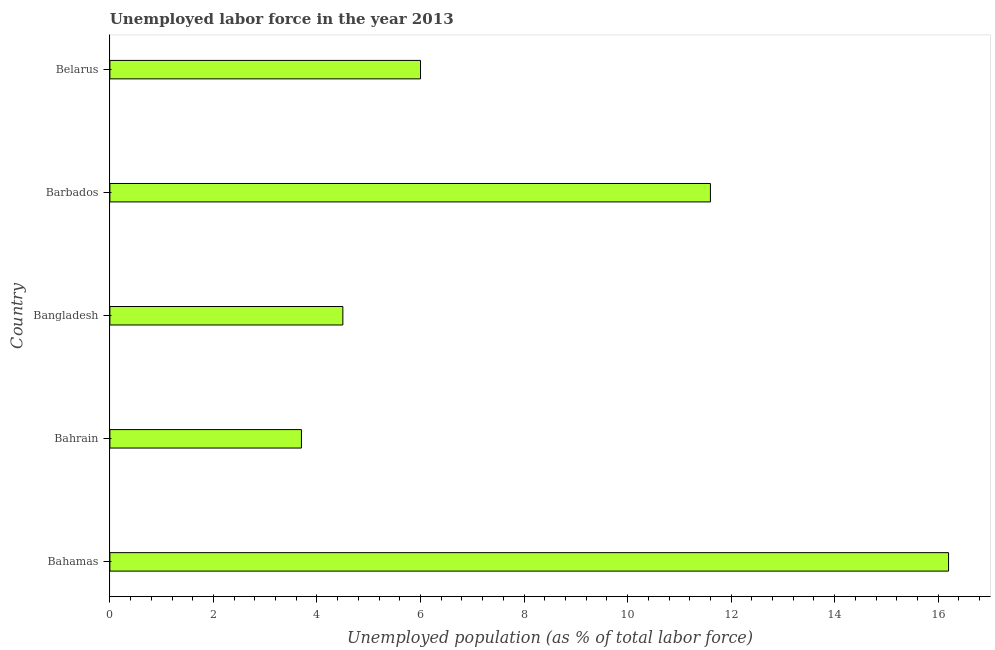Does the graph contain any zero values?
Provide a short and direct response. No. What is the title of the graph?
Your answer should be very brief. Unemployed labor force in the year 2013. What is the label or title of the X-axis?
Your response must be concise. Unemployed population (as % of total labor force). What is the label or title of the Y-axis?
Make the answer very short. Country. What is the total unemployed population in Barbados?
Your answer should be very brief. 11.6. Across all countries, what is the maximum total unemployed population?
Your answer should be very brief. 16.2. Across all countries, what is the minimum total unemployed population?
Offer a terse response. 3.7. In which country was the total unemployed population maximum?
Your answer should be compact. Bahamas. In which country was the total unemployed population minimum?
Provide a succinct answer. Bahrain. What is the sum of the total unemployed population?
Keep it short and to the point. 42. What is the difference between the total unemployed population in Bangladesh and Barbados?
Offer a very short reply. -7.1. What is the average total unemployed population per country?
Provide a succinct answer. 8.4. In how many countries, is the total unemployed population greater than 12 %?
Your answer should be compact. 1. What is the ratio of the total unemployed population in Bahrain to that in Belarus?
Provide a short and direct response. 0.62. Is the difference between the total unemployed population in Bangladesh and Barbados greater than the difference between any two countries?
Your answer should be compact. No. What is the difference between the highest and the second highest total unemployed population?
Your response must be concise. 4.6. Is the sum of the total unemployed population in Bahamas and Bahrain greater than the maximum total unemployed population across all countries?
Keep it short and to the point. Yes. In how many countries, is the total unemployed population greater than the average total unemployed population taken over all countries?
Make the answer very short. 2. How many bars are there?
Keep it short and to the point. 5. Are all the bars in the graph horizontal?
Make the answer very short. Yes. How many countries are there in the graph?
Provide a succinct answer. 5. What is the Unemployed population (as % of total labor force) in Bahamas?
Provide a succinct answer. 16.2. What is the Unemployed population (as % of total labor force) of Bahrain?
Your answer should be very brief. 3.7. What is the Unemployed population (as % of total labor force) of Bangladesh?
Provide a succinct answer. 4.5. What is the Unemployed population (as % of total labor force) in Barbados?
Offer a very short reply. 11.6. What is the Unemployed population (as % of total labor force) of Belarus?
Ensure brevity in your answer.  6. What is the difference between the Unemployed population (as % of total labor force) in Bahrain and Bangladesh?
Your answer should be compact. -0.8. What is the difference between the Unemployed population (as % of total labor force) in Bahrain and Barbados?
Give a very brief answer. -7.9. What is the difference between the Unemployed population (as % of total labor force) in Bangladesh and Barbados?
Your response must be concise. -7.1. What is the difference between the Unemployed population (as % of total labor force) in Bangladesh and Belarus?
Your answer should be very brief. -1.5. What is the ratio of the Unemployed population (as % of total labor force) in Bahamas to that in Bahrain?
Offer a terse response. 4.38. What is the ratio of the Unemployed population (as % of total labor force) in Bahamas to that in Bangladesh?
Ensure brevity in your answer.  3.6. What is the ratio of the Unemployed population (as % of total labor force) in Bahamas to that in Barbados?
Keep it short and to the point. 1.4. What is the ratio of the Unemployed population (as % of total labor force) in Bahrain to that in Bangladesh?
Ensure brevity in your answer.  0.82. What is the ratio of the Unemployed population (as % of total labor force) in Bahrain to that in Barbados?
Keep it short and to the point. 0.32. What is the ratio of the Unemployed population (as % of total labor force) in Bahrain to that in Belarus?
Ensure brevity in your answer.  0.62. What is the ratio of the Unemployed population (as % of total labor force) in Bangladesh to that in Barbados?
Your answer should be very brief. 0.39. What is the ratio of the Unemployed population (as % of total labor force) in Bangladesh to that in Belarus?
Your answer should be very brief. 0.75. What is the ratio of the Unemployed population (as % of total labor force) in Barbados to that in Belarus?
Offer a terse response. 1.93. 